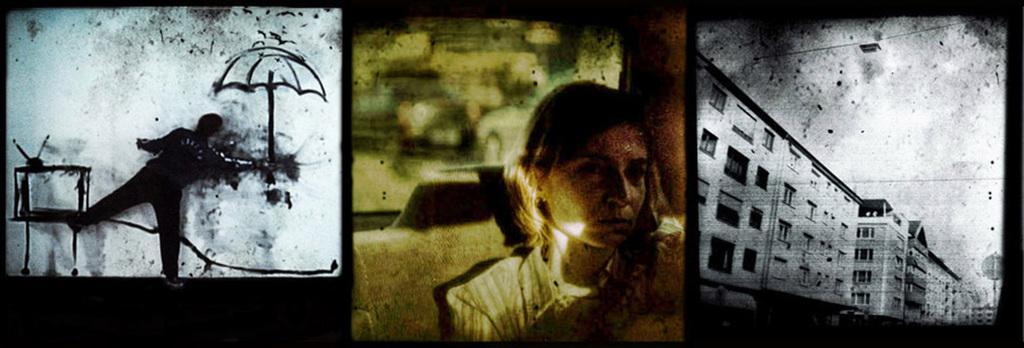Describe this image in one or two sentences. In this image I can see the collage picture in which I can see a person is standing in front of the wall and on the wall I can see the painting of an umbrella and a television. I can see a woman, a building and the sky. 